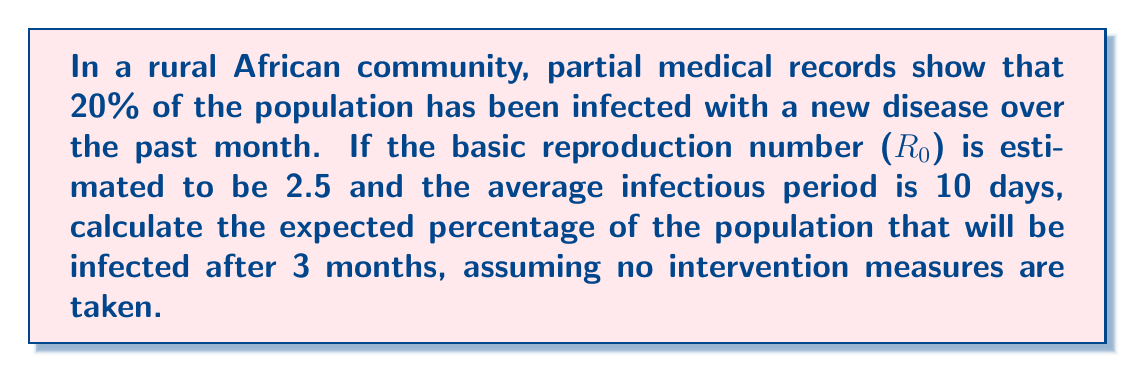Give your solution to this math problem. To solve this inverse problem, we'll use the SIR (Susceptible-Infected-Recovered) model and work backwards from the given information:

1. Given:
   - Initial infected population: 20%
   - $R_0 = 2.5$
   - Average infectious period: 10 days
   - Time period: 3 months (90 days)

2. Calculate the recovery rate $\gamma$:
   $\gamma = \frac{1}{\text{average infectious period}} = \frac{1}{10} = 0.1$ per day

3. Calculate the transmission rate $\beta$:
   $R_0 = \frac{\beta}{\gamma}$
   $\beta = R_0 \cdot \gamma = 2.5 \cdot 0.1 = 0.25$ per day

4. Use the SIR model differential equations:
   $$\frac{dS}{dt} = -\beta SI$$
   $$\frac{dI}{dt} = \beta SI - \gamma I$$
   $$\frac{dR}{dt} = \gamma I$$

5. Solve the system of equations numerically using the Runge-Kutta method or a similar numerical integration technique. This step requires computational tools.

6. Initial conditions:
   $S_0 = 0.8$ (80% susceptible)
   $I_0 = 0.2$ (20% infected)
   $R_0 = 0$ (0% recovered)

7. After numerical integration for 90 days, we find:
   $S_{90} \approx 0.11$ (11% susceptible)
   $I_{90} \approx 0.05$ (5% infected)
   $R_{90} \approx 0.84$ (84% recovered)

8. The total percentage of the population that will have been infected is:
   $\text{Total Infected} = 1 - S_{90} = 1 - 0.11 = 0.89$ or 89%
Answer: 89% 